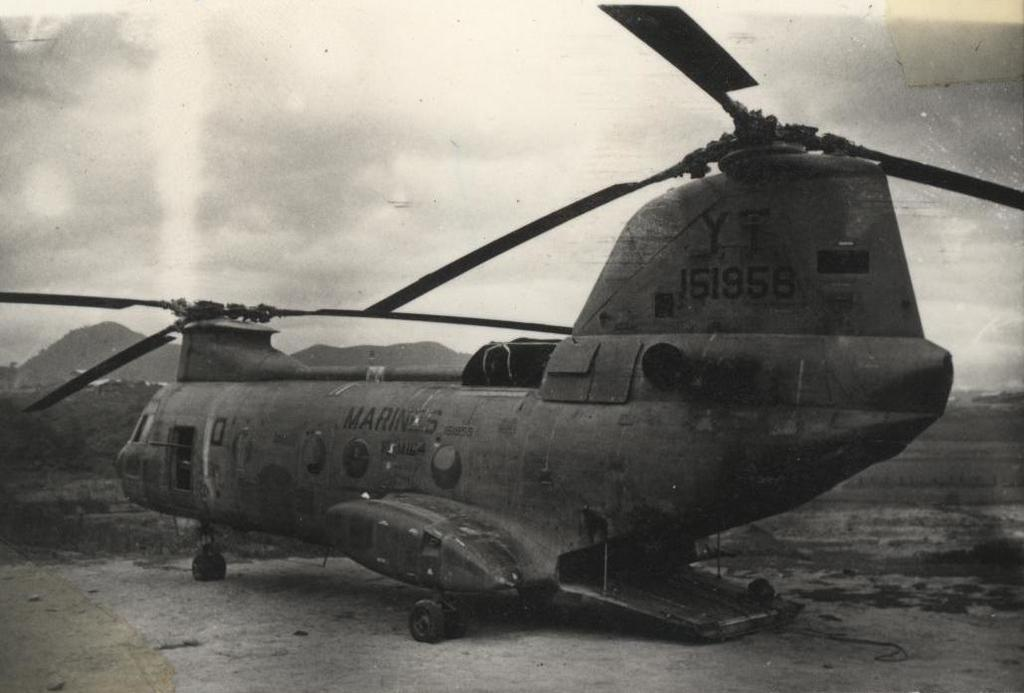What is the main subject of the image? The main subject of the image is an airplane on the ground. What can be seen in the background of the image? Mountains are visible in the background of the image. What is visible in the sky in the image? The sky is visible in the background of the image, and clouds are present. What type of silk fabric is draped over the lettuce in the image? There is no silk or lettuce present in the image; it features an airplane on the ground with mountains and clouds in the background. 